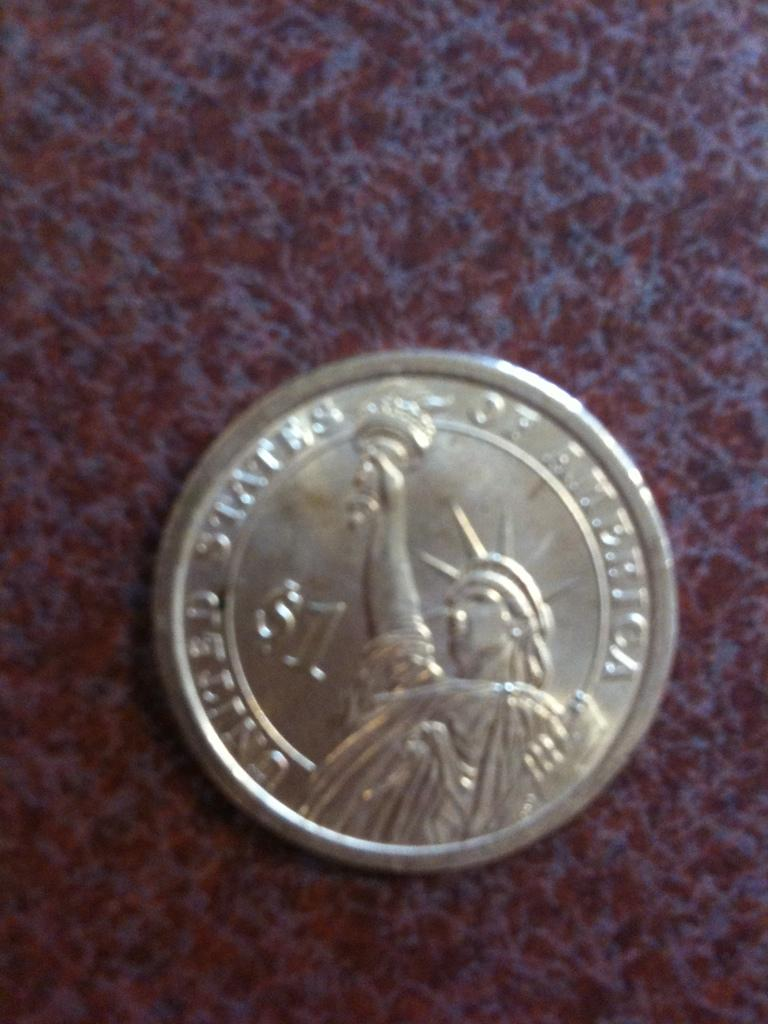<image>
Provide a brief description of the given image. On a counter there is a one dollar coin that says United States of America. 